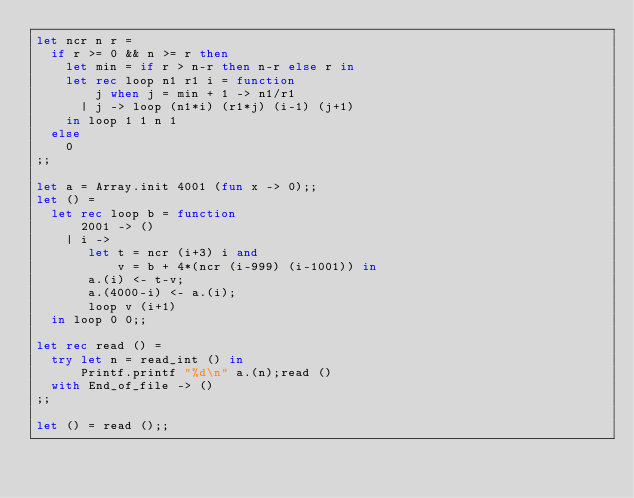<code> <loc_0><loc_0><loc_500><loc_500><_OCaml_>let ncr n r =
  if r >= 0 && n >= r then
    let min = if r > n-r then n-r else r in
    let rec loop n1 r1 i = function
        j when j = min + 1 -> n1/r1
      | j -> loop (n1*i) (r1*j) (i-1) (j+1)
    in loop 1 1 n 1
  else
    0
;;

let a = Array.init 4001 (fun x -> 0);;
let () =
  let rec loop b = function
      2001 -> ()
    | i ->
       let t = ncr (i+3) i and
           v = b + 4*(ncr (i-999) (i-1001)) in
       a.(i) <- t-v;
       a.(4000-i) <- a.(i);
       loop v (i+1)
  in loop 0 0;;

let rec read () =
  try let n = read_int () in
      Printf.printf "%d\n" a.(n);read ()
  with End_of_file -> ()
;;

let () = read ();;</code> 